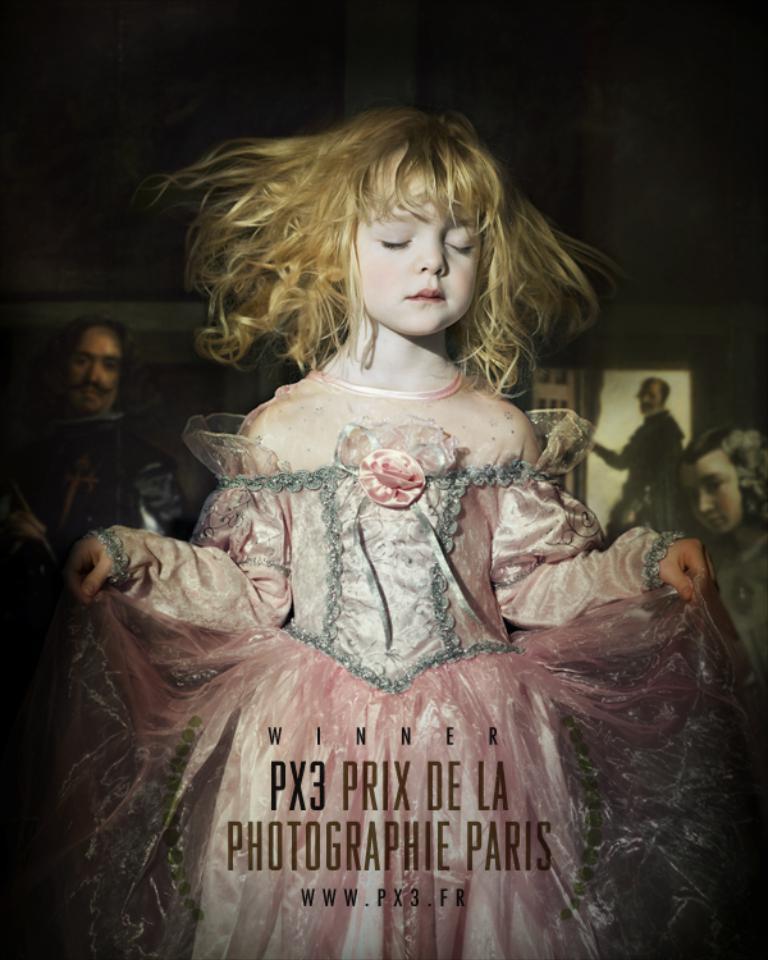Please provide a concise description of this image. In the picture we can see a girl with pink color dress and she is holding it and closing her hands and she is with golden hair and behind her we can see some people are standing and watching her and on the girl dress we can see a name PX3 PRIX DE LA photographie Paris. 